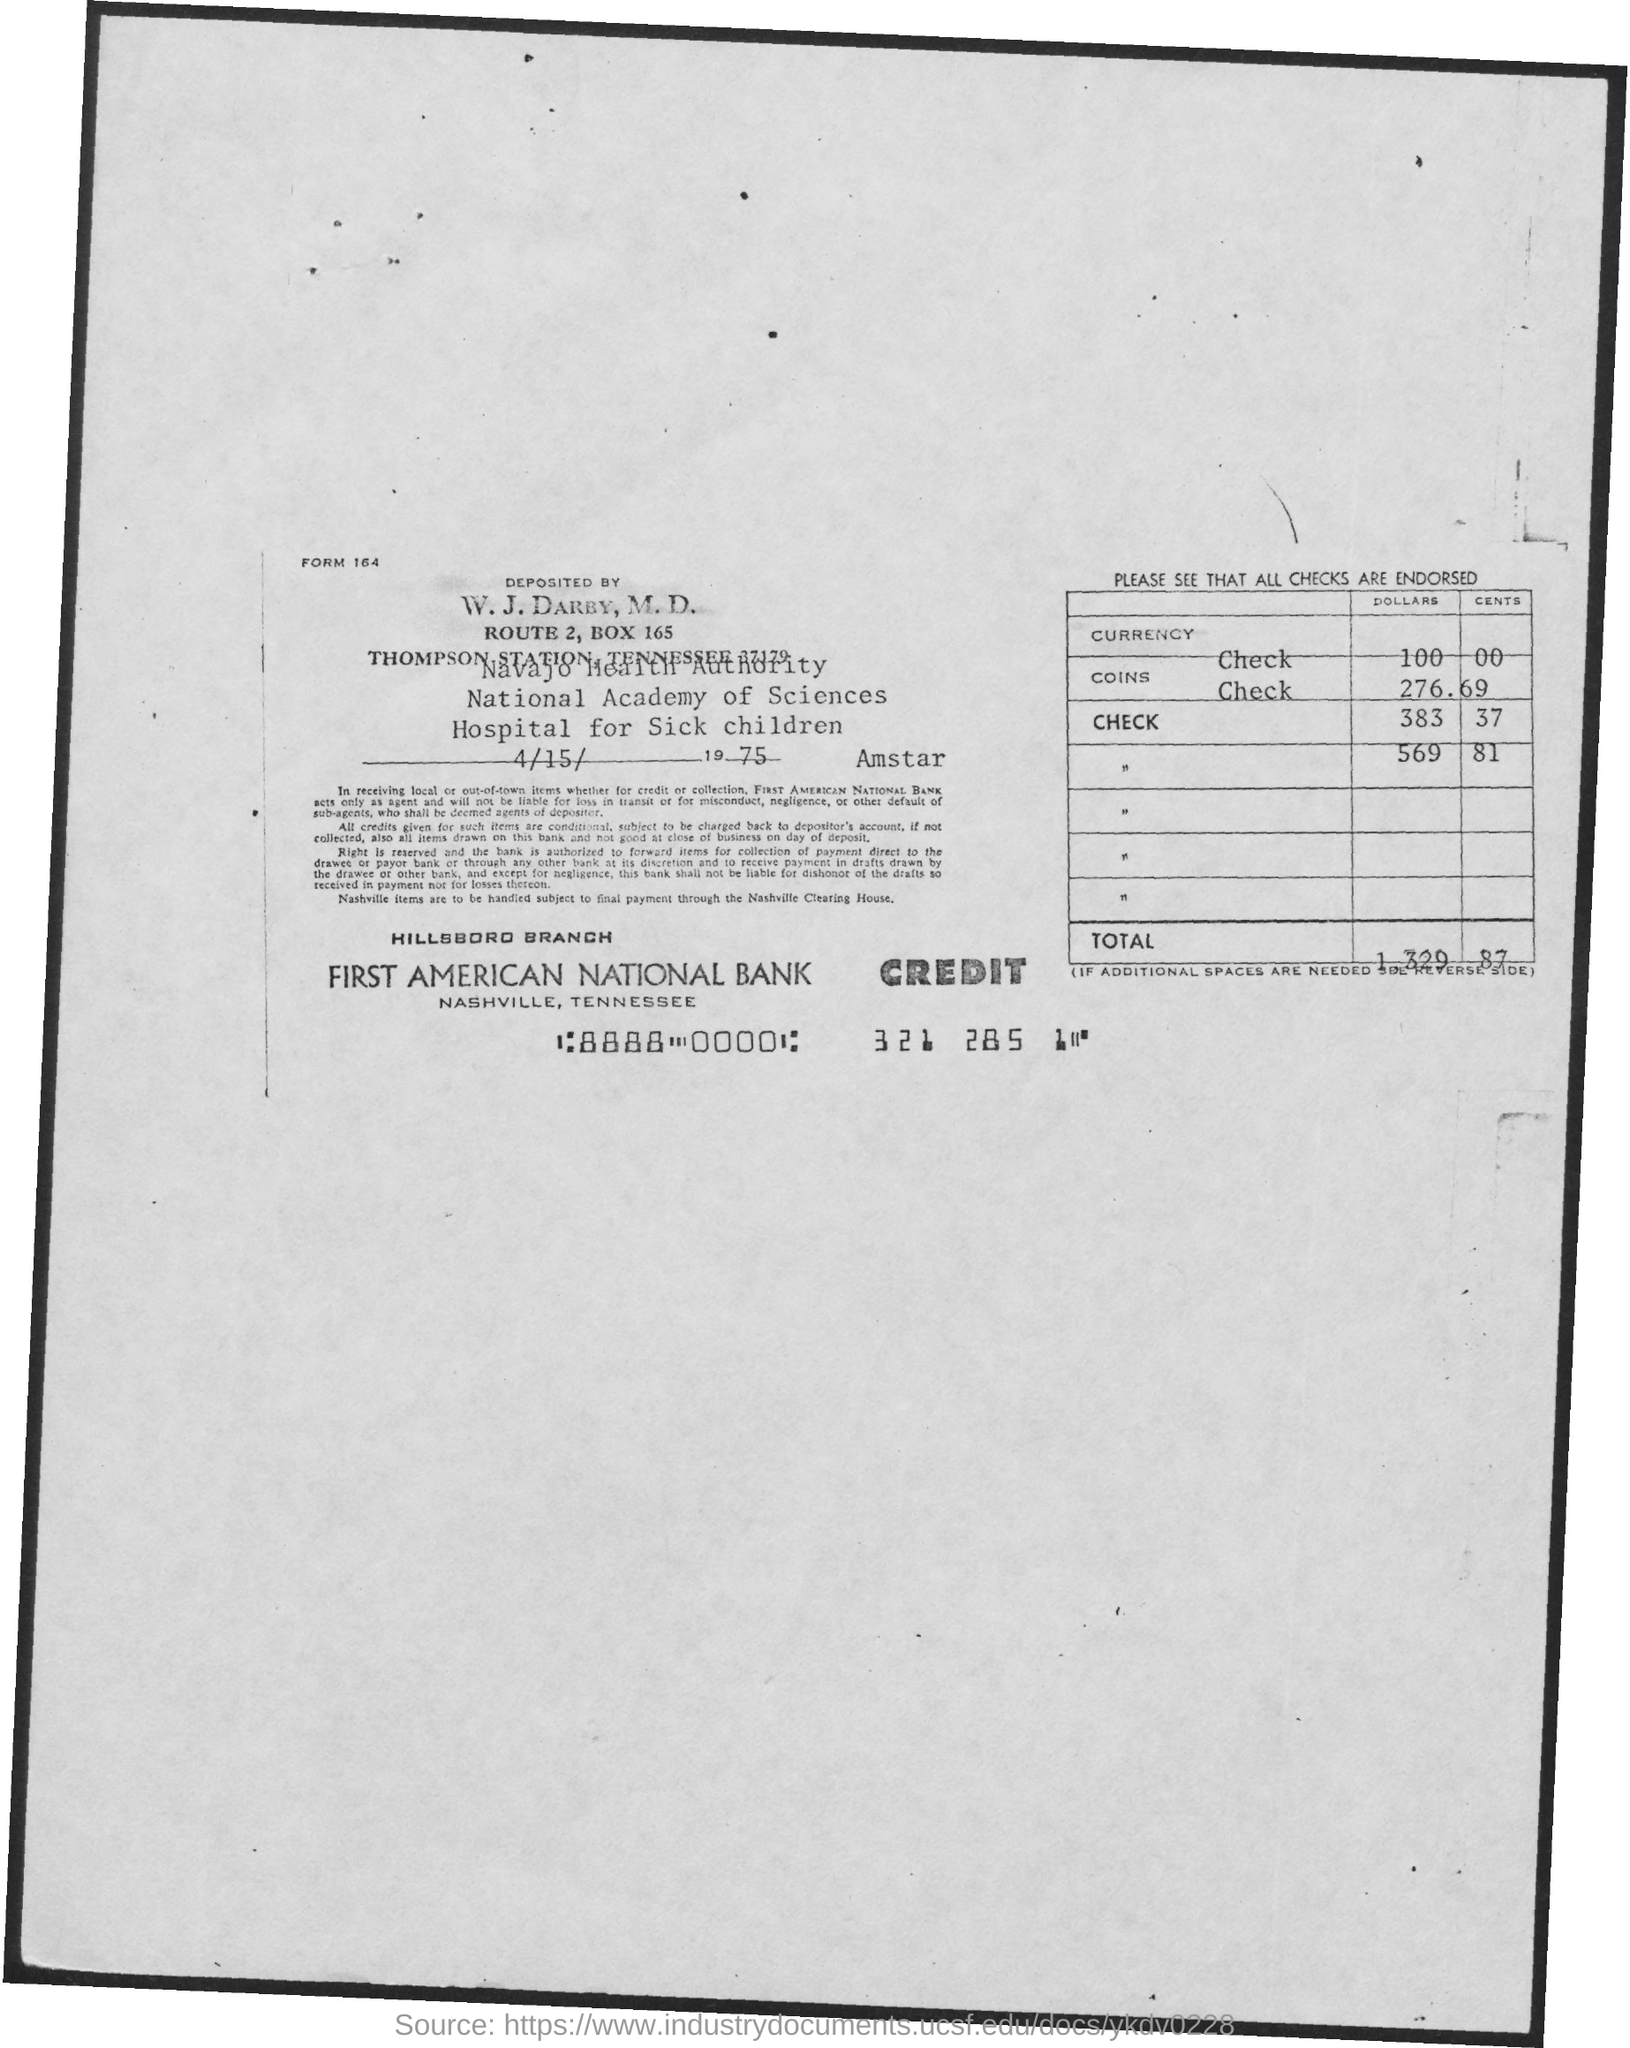What is the form no.?
Provide a short and direct response. 164. What is the date of deposit?
Give a very brief answer. 4/15/1975. What is the total amount ?
Your response must be concise. $1,329.87. What is the name of the bank?
Your answer should be compact. First American National Bank. What is the address of first american national bank?
Keep it short and to the point. Nashville, Tennessee. 